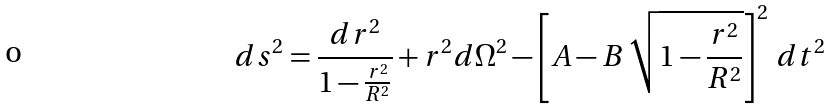Convert formula to latex. <formula><loc_0><loc_0><loc_500><loc_500>d s ^ { 2 } = \frac { d r ^ { 2 } } { 1 - \frac { r ^ { 2 } } { R ^ { 2 } } } + r ^ { 2 } d \Omega ^ { 2 } - \left [ A - B \, \sqrt { 1 - \frac { r ^ { 2 } } { R ^ { 2 } } } \right ] ^ { 2 } \, d t ^ { 2 }</formula> 